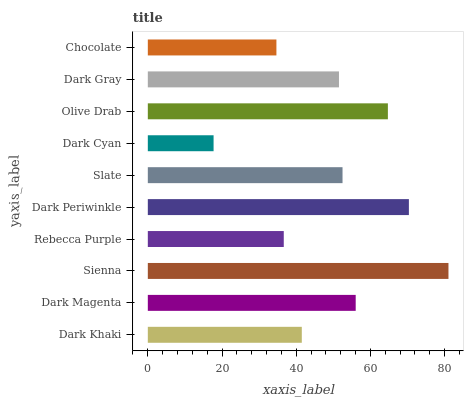Is Dark Cyan the minimum?
Answer yes or no. Yes. Is Sienna the maximum?
Answer yes or no. Yes. Is Dark Magenta the minimum?
Answer yes or no. No. Is Dark Magenta the maximum?
Answer yes or no. No. Is Dark Magenta greater than Dark Khaki?
Answer yes or no. Yes. Is Dark Khaki less than Dark Magenta?
Answer yes or no. Yes. Is Dark Khaki greater than Dark Magenta?
Answer yes or no. No. Is Dark Magenta less than Dark Khaki?
Answer yes or no. No. Is Slate the high median?
Answer yes or no. Yes. Is Dark Gray the low median?
Answer yes or no. Yes. Is Olive Drab the high median?
Answer yes or no. No. Is Rebecca Purple the low median?
Answer yes or no. No. 